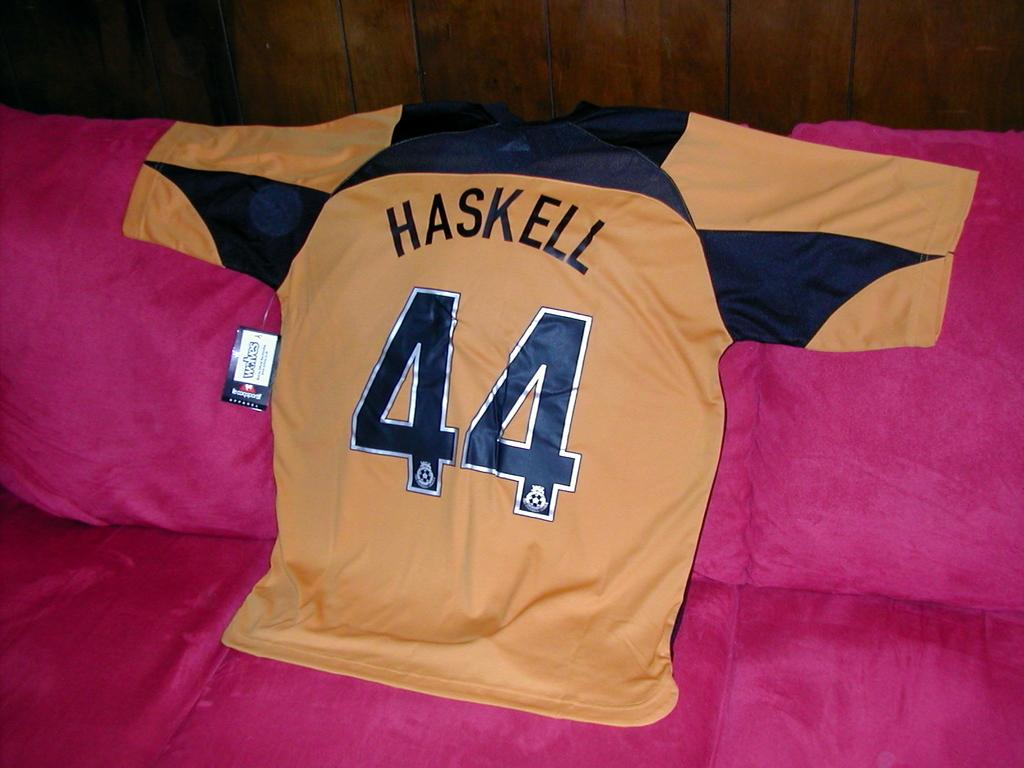<image>
Provide a brief description of the given image. a jersey with the number 44 on it 